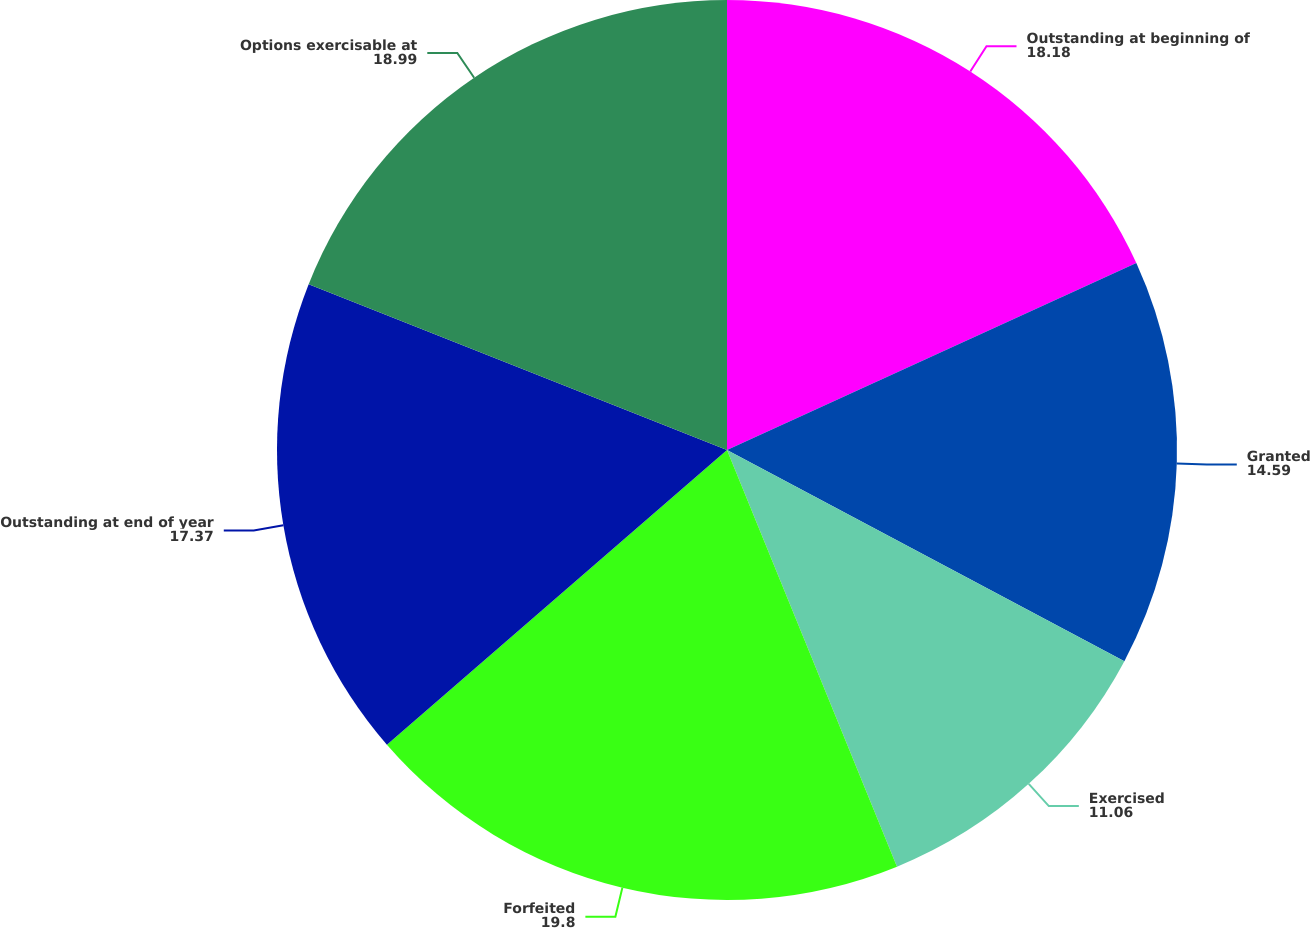<chart> <loc_0><loc_0><loc_500><loc_500><pie_chart><fcel>Outstanding at beginning of<fcel>Granted<fcel>Exercised<fcel>Forfeited<fcel>Outstanding at end of year<fcel>Options exercisable at<nl><fcel>18.18%<fcel>14.59%<fcel>11.06%<fcel>19.8%<fcel>17.37%<fcel>18.99%<nl></chart> 